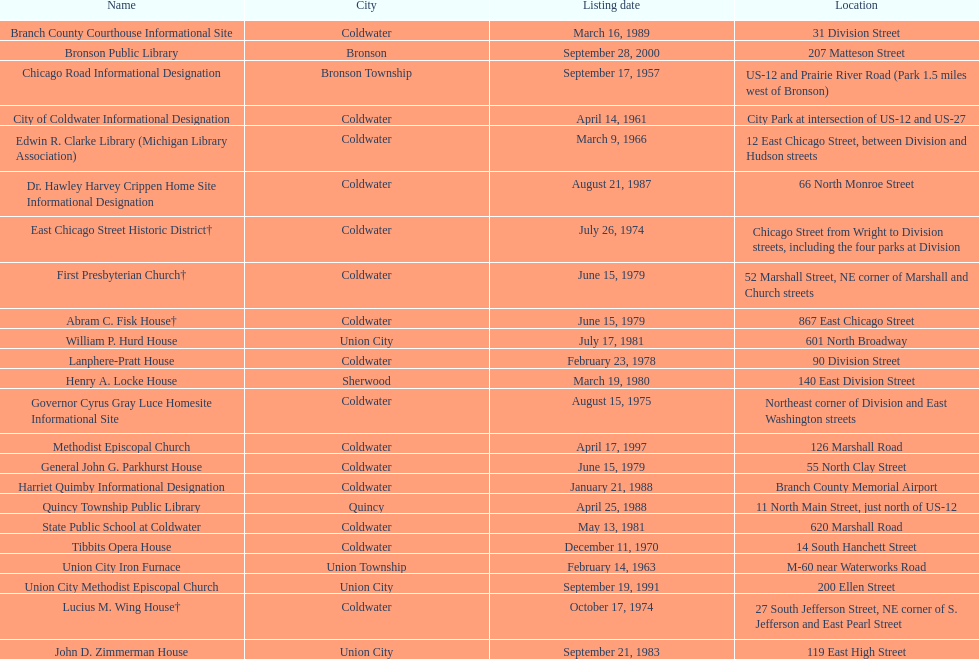What is the name with the only listing date on april 14, 1961 City of Coldwater. 